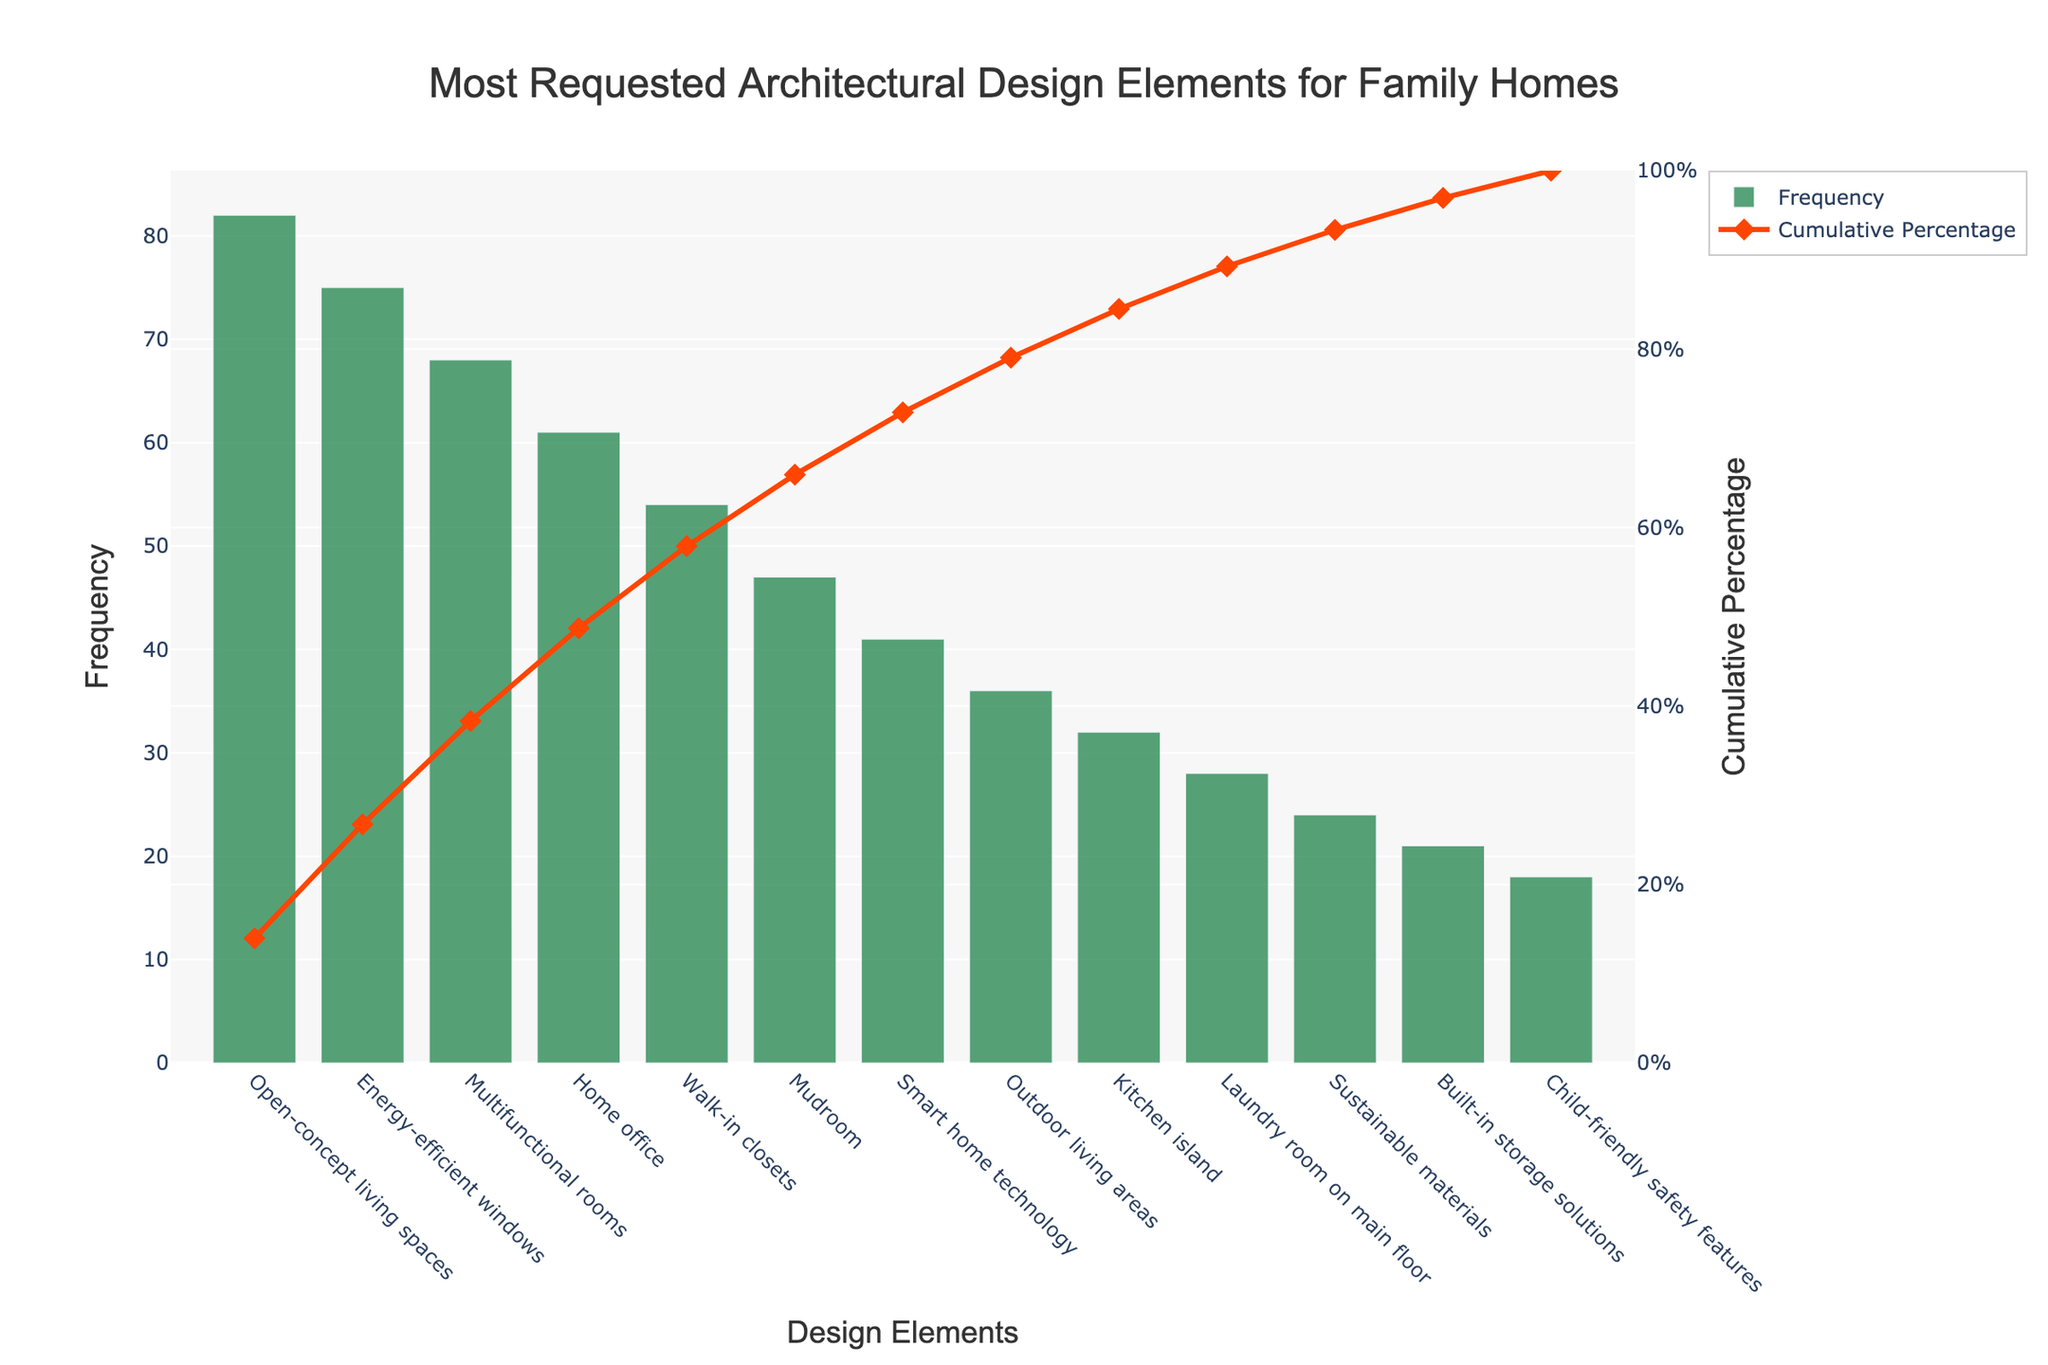What's the title of the chart? The title of the chart is located at the top and reads "Most Requested Architectural Design Elements for Family Homes".
Answer: Most Requested Architectural Design Elements for Family Homes How many design elements are listed in total? Counting all the individual design elements listed on the x-axis shows that there are 13 design elements in total.
Answer: 13 Which design element has the highest frequency and what is its value? The design element with the highest bar is "Open-concept living spaces" with a frequency value indicated by the top of the bar at 82.
Answer: Open-concept living spaces, 82 What is the cumulative percentage for "Home office"? The line graph shows the cumulative percentage for each design element. For "Home office", the corresponding point on the red line shows a value around 57%.
Answer: Approximately 57% What is the difference in frequency between "Energy-efficient windows" and "Smart home technology"? Subtract the frequency of "Smart home technology" (41) from "Energy-efficient windows" (75), resulting in 75 - 41 = 34.
Answer: 34 Which design elements together constitute approximately 50% of the cumulative percentage? By following the cumulative percentage line graph until it reaches approximately 50%, "Open-concept living spaces" (82), "Energy-efficient windows" (75), and "Multifunctional rooms" (68) together make up around 50%.
Answer: Open-concept living spaces, Energy-efficient windows, Multifunctional rooms Which design element is the least requested and what is its frequency? The bar with the lowest height is "Child-friendly safety features" with a frequency shown at the top of the bar as 18.
Answer: Child-friendly safety features, 18 What is the sum of frequencies for the design elements "Walk-in closets" and "Mudroom"? Add the frequencies of "Walk-in closets" (54) and "Mudroom" (47), resulting in 54 + 47 = 101.
Answer: 101 How does the frequency of "Outdoor living areas" compare to "Laundry room on main floor"? The bar for "Outdoor living areas" has a frequency of 36, while "Laundry room on main floor" has a frequency of 28. Therefore, "Outdoor living areas" has a higher frequency by 8.
Answer: Outdoor living areas has 8 more than Laundry room on main floor What cumulative percentage does the first five design elements make up? Add the frequencies of the first five design elements: 82 (Open-concept living spaces) + 75 (Energy-efficient windows) + 68 (Multifunctional rooms) + 61 (Home office) + 54 (Walk-in closets) = 340. Calculate 340 / total frequency sum of 577 * 100 = approximately 59%.
Answer: Approximately 59% 